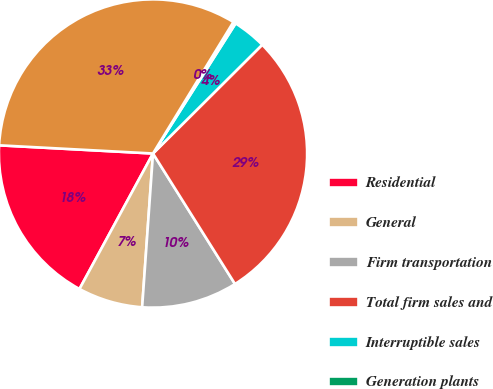<chart> <loc_0><loc_0><loc_500><loc_500><pie_chart><fcel>Residential<fcel>General<fcel>Firm transportation<fcel>Total firm sales and<fcel>Interruptible sales<fcel>Generation plants<fcel>Total<nl><fcel>17.93%<fcel>6.79%<fcel>10.05%<fcel>28.53%<fcel>3.53%<fcel>0.27%<fcel>32.88%<nl></chart> 